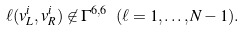<formula> <loc_0><loc_0><loc_500><loc_500>\ell ( v _ { L } ^ { i } , v _ { R } ^ { i } ) \not \in \Gamma ^ { 6 , 6 } \ ( \ell = 1 , \dots , N - 1 ) .</formula> 